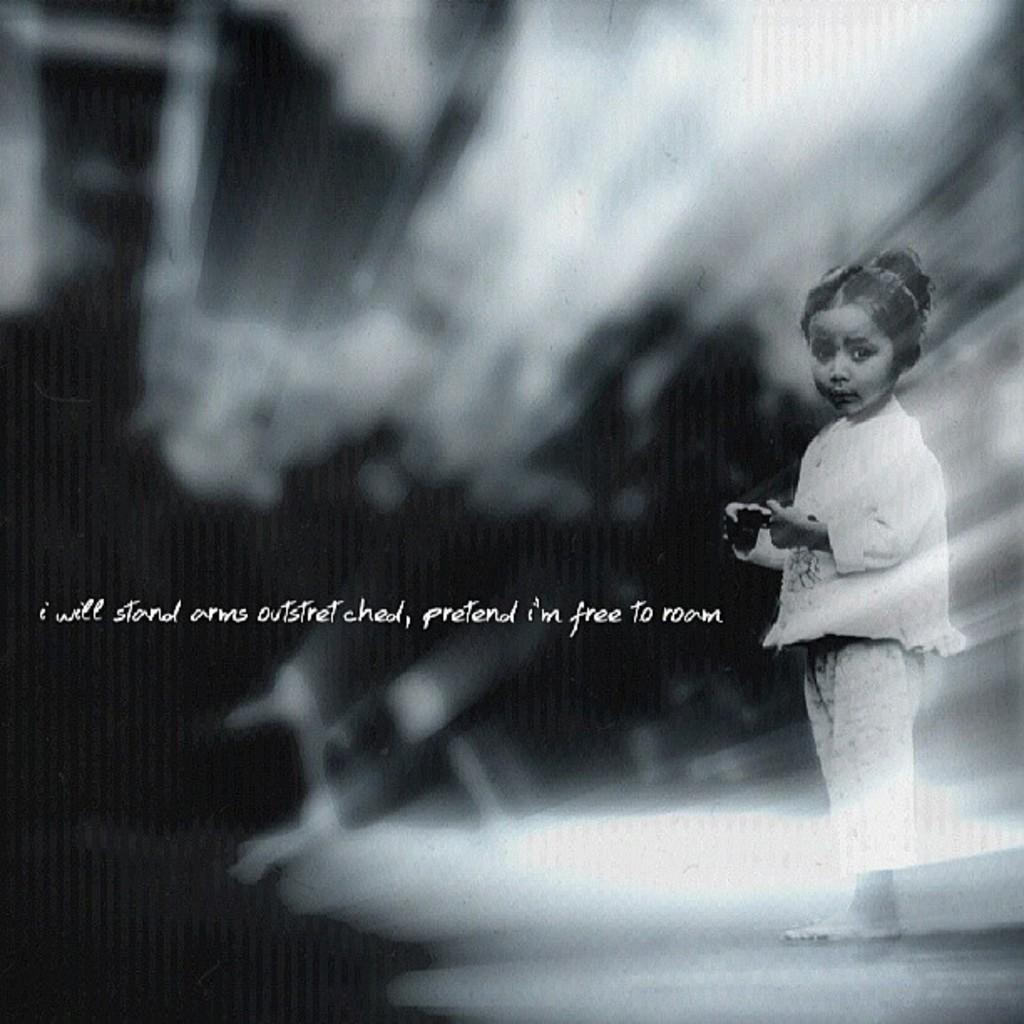What is the color scheme of the image? The image is black and white. Can you describe the main subject of the image? There is a girl in the image. Are there any textual elements in the image? Yes, there are words written in the image. What brand of toothpaste is being advertised in the image? There is no toothpaste or advertisement present in the image. What type of list can be seen in the image? There is no list present in the image. 